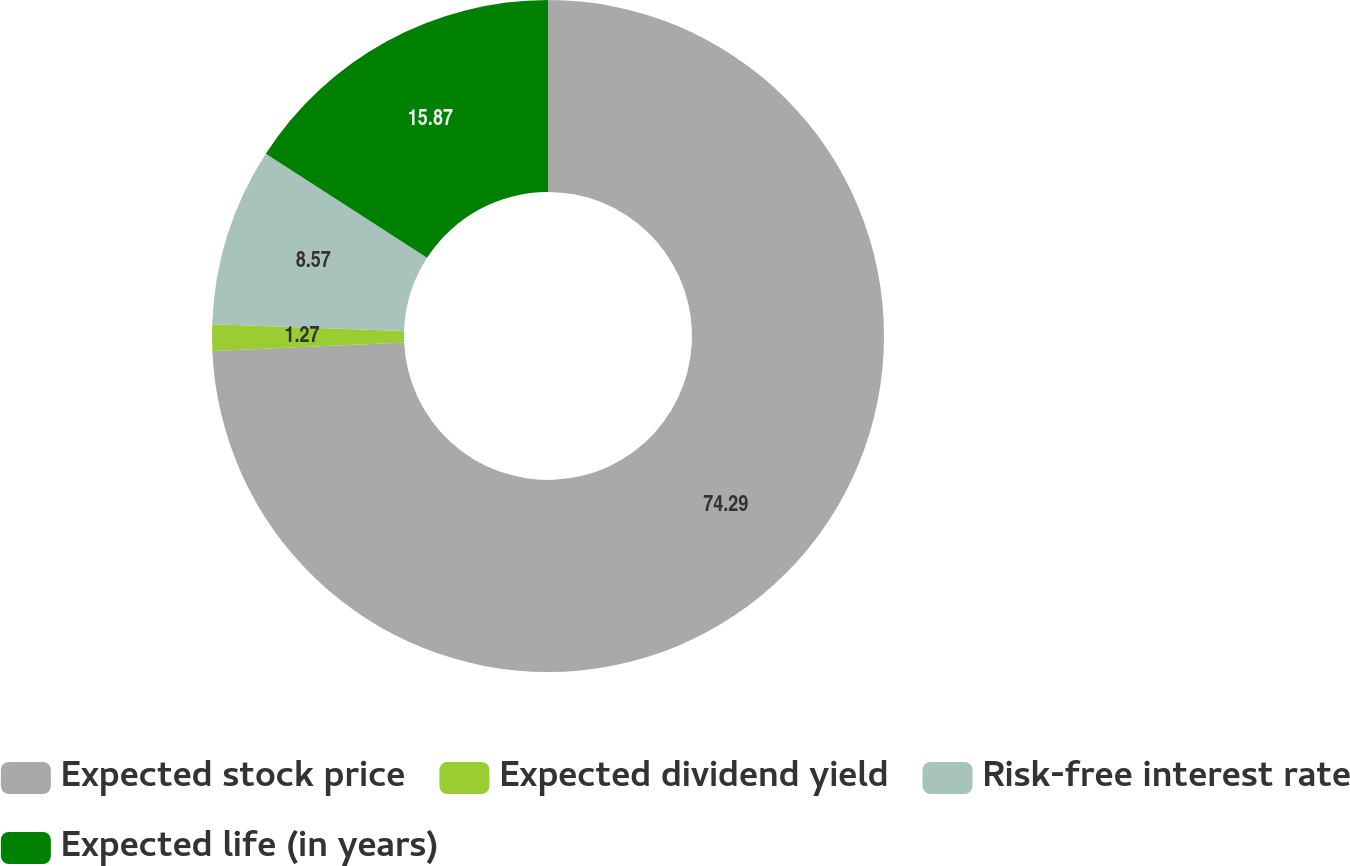<chart> <loc_0><loc_0><loc_500><loc_500><pie_chart><fcel>Expected stock price<fcel>Expected dividend yield<fcel>Risk-free interest rate<fcel>Expected life (in years)<nl><fcel>74.29%<fcel>1.27%<fcel>8.57%<fcel>15.87%<nl></chart> 